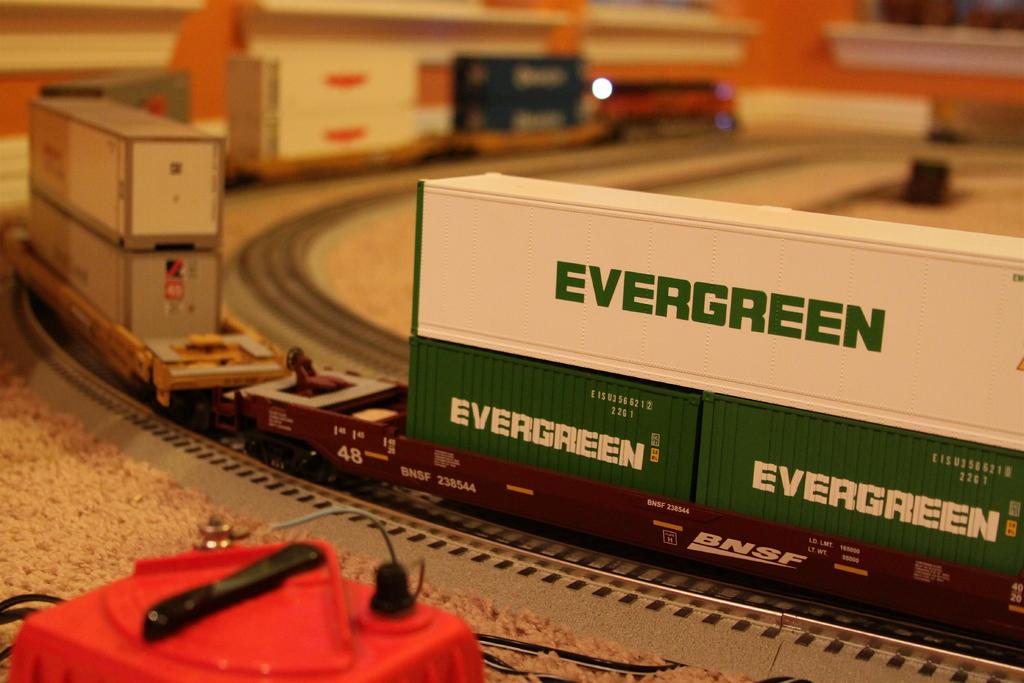What company is advertised on the toy train?
Ensure brevity in your answer.  Evergreen. What's the name of the railway?
Your answer should be very brief. Evergreen. 